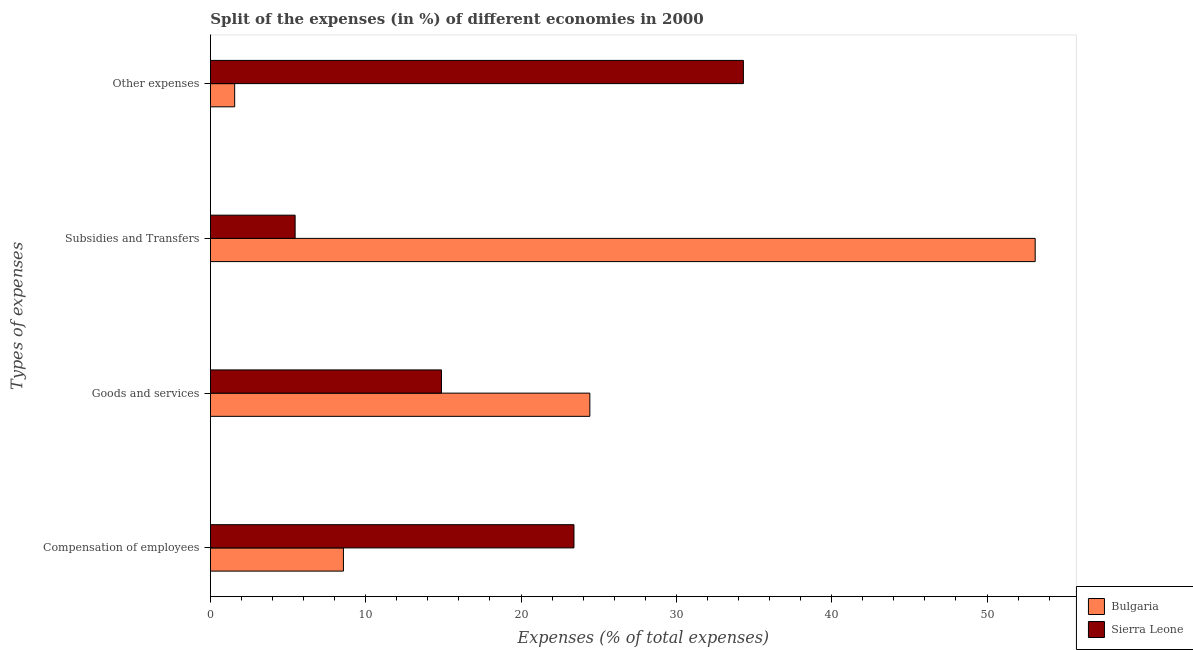How many different coloured bars are there?
Ensure brevity in your answer.  2. How many groups of bars are there?
Provide a succinct answer. 4. Are the number of bars on each tick of the Y-axis equal?
Your answer should be compact. Yes. How many bars are there on the 1st tick from the top?
Make the answer very short. 2. How many bars are there on the 1st tick from the bottom?
Your response must be concise. 2. What is the label of the 2nd group of bars from the top?
Provide a short and direct response. Subsidies and Transfers. What is the percentage of amount spent on subsidies in Sierra Leone?
Your answer should be compact. 5.46. Across all countries, what is the maximum percentage of amount spent on other expenses?
Keep it short and to the point. 34.31. Across all countries, what is the minimum percentage of amount spent on other expenses?
Your answer should be very brief. 1.56. In which country was the percentage of amount spent on goods and services maximum?
Your answer should be compact. Bulgaria. In which country was the percentage of amount spent on subsidies minimum?
Keep it short and to the point. Sierra Leone. What is the total percentage of amount spent on other expenses in the graph?
Ensure brevity in your answer.  35.88. What is the difference between the percentage of amount spent on subsidies in Sierra Leone and that in Bulgaria?
Give a very brief answer. -47.64. What is the difference between the percentage of amount spent on compensation of employees in Bulgaria and the percentage of amount spent on goods and services in Sierra Leone?
Offer a terse response. -6.31. What is the average percentage of amount spent on other expenses per country?
Make the answer very short. 17.94. What is the difference between the percentage of amount spent on goods and services and percentage of amount spent on compensation of employees in Sierra Leone?
Offer a very short reply. -8.53. What is the ratio of the percentage of amount spent on goods and services in Sierra Leone to that in Bulgaria?
Make the answer very short. 0.61. Is the percentage of amount spent on subsidies in Sierra Leone less than that in Bulgaria?
Provide a short and direct response. Yes. Is the difference between the percentage of amount spent on subsidies in Bulgaria and Sierra Leone greater than the difference between the percentage of amount spent on goods and services in Bulgaria and Sierra Leone?
Make the answer very short. Yes. What is the difference between the highest and the second highest percentage of amount spent on other expenses?
Your answer should be very brief. 32.75. What is the difference between the highest and the lowest percentage of amount spent on other expenses?
Offer a very short reply. 32.75. In how many countries, is the percentage of amount spent on other expenses greater than the average percentage of amount spent on other expenses taken over all countries?
Make the answer very short. 1. Is it the case that in every country, the sum of the percentage of amount spent on goods and services and percentage of amount spent on compensation of employees is greater than the sum of percentage of amount spent on subsidies and percentage of amount spent on other expenses?
Your response must be concise. No. What does the 2nd bar from the top in Compensation of employees represents?
Your answer should be very brief. Bulgaria. What does the 2nd bar from the bottom in Goods and services represents?
Provide a succinct answer. Sierra Leone. Is it the case that in every country, the sum of the percentage of amount spent on compensation of employees and percentage of amount spent on goods and services is greater than the percentage of amount spent on subsidies?
Ensure brevity in your answer.  No. How many bars are there?
Your answer should be very brief. 8. Are the values on the major ticks of X-axis written in scientific E-notation?
Your response must be concise. No. Does the graph contain any zero values?
Your answer should be compact. No. Does the graph contain grids?
Offer a terse response. No. Where does the legend appear in the graph?
Keep it short and to the point. Bottom right. How are the legend labels stacked?
Keep it short and to the point. Vertical. What is the title of the graph?
Offer a terse response. Split of the expenses (in %) of different economies in 2000. What is the label or title of the X-axis?
Offer a terse response. Expenses (% of total expenses). What is the label or title of the Y-axis?
Give a very brief answer. Types of expenses. What is the Expenses (% of total expenses) of Bulgaria in Compensation of employees?
Your response must be concise. 8.57. What is the Expenses (% of total expenses) in Sierra Leone in Compensation of employees?
Keep it short and to the point. 23.41. What is the Expenses (% of total expenses) in Bulgaria in Goods and services?
Provide a short and direct response. 24.43. What is the Expenses (% of total expenses) of Sierra Leone in Goods and services?
Your answer should be compact. 14.88. What is the Expenses (% of total expenses) in Bulgaria in Subsidies and Transfers?
Provide a succinct answer. 53.1. What is the Expenses (% of total expenses) of Sierra Leone in Subsidies and Transfers?
Your answer should be very brief. 5.46. What is the Expenses (% of total expenses) in Bulgaria in Other expenses?
Provide a short and direct response. 1.56. What is the Expenses (% of total expenses) of Sierra Leone in Other expenses?
Offer a very short reply. 34.31. Across all Types of expenses, what is the maximum Expenses (% of total expenses) of Bulgaria?
Make the answer very short. 53.1. Across all Types of expenses, what is the maximum Expenses (% of total expenses) of Sierra Leone?
Give a very brief answer. 34.31. Across all Types of expenses, what is the minimum Expenses (% of total expenses) in Bulgaria?
Offer a very short reply. 1.56. Across all Types of expenses, what is the minimum Expenses (% of total expenses) in Sierra Leone?
Provide a short and direct response. 5.46. What is the total Expenses (% of total expenses) in Bulgaria in the graph?
Give a very brief answer. 87.66. What is the total Expenses (% of total expenses) in Sierra Leone in the graph?
Give a very brief answer. 78.05. What is the difference between the Expenses (% of total expenses) of Bulgaria in Compensation of employees and that in Goods and services?
Provide a short and direct response. -15.86. What is the difference between the Expenses (% of total expenses) in Sierra Leone in Compensation of employees and that in Goods and services?
Your answer should be compact. 8.53. What is the difference between the Expenses (% of total expenses) in Bulgaria in Compensation of employees and that in Subsidies and Transfers?
Your answer should be compact. -44.53. What is the difference between the Expenses (% of total expenses) of Sierra Leone in Compensation of employees and that in Subsidies and Transfers?
Your response must be concise. 17.95. What is the difference between the Expenses (% of total expenses) in Bulgaria in Compensation of employees and that in Other expenses?
Give a very brief answer. 7. What is the difference between the Expenses (% of total expenses) of Sierra Leone in Compensation of employees and that in Other expenses?
Give a very brief answer. -10.91. What is the difference between the Expenses (% of total expenses) in Bulgaria in Goods and services and that in Subsidies and Transfers?
Provide a short and direct response. -28.67. What is the difference between the Expenses (% of total expenses) of Sierra Leone in Goods and services and that in Subsidies and Transfers?
Make the answer very short. 9.42. What is the difference between the Expenses (% of total expenses) in Bulgaria in Goods and services and that in Other expenses?
Keep it short and to the point. 22.87. What is the difference between the Expenses (% of total expenses) in Sierra Leone in Goods and services and that in Other expenses?
Your response must be concise. -19.44. What is the difference between the Expenses (% of total expenses) of Bulgaria in Subsidies and Transfers and that in Other expenses?
Your answer should be very brief. 51.54. What is the difference between the Expenses (% of total expenses) in Sierra Leone in Subsidies and Transfers and that in Other expenses?
Provide a succinct answer. -28.86. What is the difference between the Expenses (% of total expenses) in Bulgaria in Compensation of employees and the Expenses (% of total expenses) in Sierra Leone in Goods and services?
Your answer should be very brief. -6.31. What is the difference between the Expenses (% of total expenses) of Bulgaria in Compensation of employees and the Expenses (% of total expenses) of Sierra Leone in Subsidies and Transfers?
Provide a succinct answer. 3.11. What is the difference between the Expenses (% of total expenses) of Bulgaria in Compensation of employees and the Expenses (% of total expenses) of Sierra Leone in Other expenses?
Offer a very short reply. -25.75. What is the difference between the Expenses (% of total expenses) in Bulgaria in Goods and services and the Expenses (% of total expenses) in Sierra Leone in Subsidies and Transfers?
Keep it short and to the point. 18.97. What is the difference between the Expenses (% of total expenses) of Bulgaria in Goods and services and the Expenses (% of total expenses) of Sierra Leone in Other expenses?
Give a very brief answer. -9.88. What is the difference between the Expenses (% of total expenses) of Bulgaria in Subsidies and Transfers and the Expenses (% of total expenses) of Sierra Leone in Other expenses?
Ensure brevity in your answer.  18.79. What is the average Expenses (% of total expenses) in Bulgaria per Types of expenses?
Ensure brevity in your answer.  21.91. What is the average Expenses (% of total expenses) of Sierra Leone per Types of expenses?
Make the answer very short. 19.51. What is the difference between the Expenses (% of total expenses) in Bulgaria and Expenses (% of total expenses) in Sierra Leone in Compensation of employees?
Make the answer very short. -14.84. What is the difference between the Expenses (% of total expenses) of Bulgaria and Expenses (% of total expenses) of Sierra Leone in Goods and services?
Make the answer very short. 9.55. What is the difference between the Expenses (% of total expenses) of Bulgaria and Expenses (% of total expenses) of Sierra Leone in Subsidies and Transfers?
Offer a very short reply. 47.64. What is the difference between the Expenses (% of total expenses) of Bulgaria and Expenses (% of total expenses) of Sierra Leone in Other expenses?
Offer a very short reply. -32.75. What is the ratio of the Expenses (% of total expenses) of Bulgaria in Compensation of employees to that in Goods and services?
Offer a very short reply. 0.35. What is the ratio of the Expenses (% of total expenses) in Sierra Leone in Compensation of employees to that in Goods and services?
Make the answer very short. 1.57. What is the ratio of the Expenses (% of total expenses) in Bulgaria in Compensation of employees to that in Subsidies and Transfers?
Give a very brief answer. 0.16. What is the ratio of the Expenses (% of total expenses) of Sierra Leone in Compensation of employees to that in Subsidies and Transfers?
Provide a succinct answer. 4.29. What is the ratio of the Expenses (% of total expenses) of Bulgaria in Compensation of employees to that in Other expenses?
Offer a very short reply. 5.48. What is the ratio of the Expenses (% of total expenses) of Sierra Leone in Compensation of employees to that in Other expenses?
Your answer should be very brief. 0.68. What is the ratio of the Expenses (% of total expenses) in Bulgaria in Goods and services to that in Subsidies and Transfers?
Keep it short and to the point. 0.46. What is the ratio of the Expenses (% of total expenses) of Sierra Leone in Goods and services to that in Subsidies and Transfers?
Provide a short and direct response. 2.73. What is the ratio of the Expenses (% of total expenses) of Bulgaria in Goods and services to that in Other expenses?
Provide a short and direct response. 15.62. What is the ratio of the Expenses (% of total expenses) in Sierra Leone in Goods and services to that in Other expenses?
Your answer should be very brief. 0.43. What is the ratio of the Expenses (% of total expenses) of Bulgaria in Subsidies and Transfers to that in Other expenses?
Give a very brief answer. 33.96. What is the ratio of the Expenses (% of total expenses) in Sierra Leone in Subsidies and Transfers to that in Other expenses?
Keep it short and to the point. 0.16. What is the difference between the highest and the second highest Expenses (% of total expenses) of Bulgaria?
Provide a succinct answer. 28.67. What is the difference between the highest and the second highest Expenses (% of total expenses) in Sierra Leone?
Keep it short and to the point. 10.91. What is the difference between the highest and the lowest Expenses (% of total expenses) of Bulgaria?
Keep it short and to the point. 51.54. What is the difference between the highest and the lowest Expenses (% of total expenses) of Sierra Leone?
Provide a succinct answer. 28.86. 